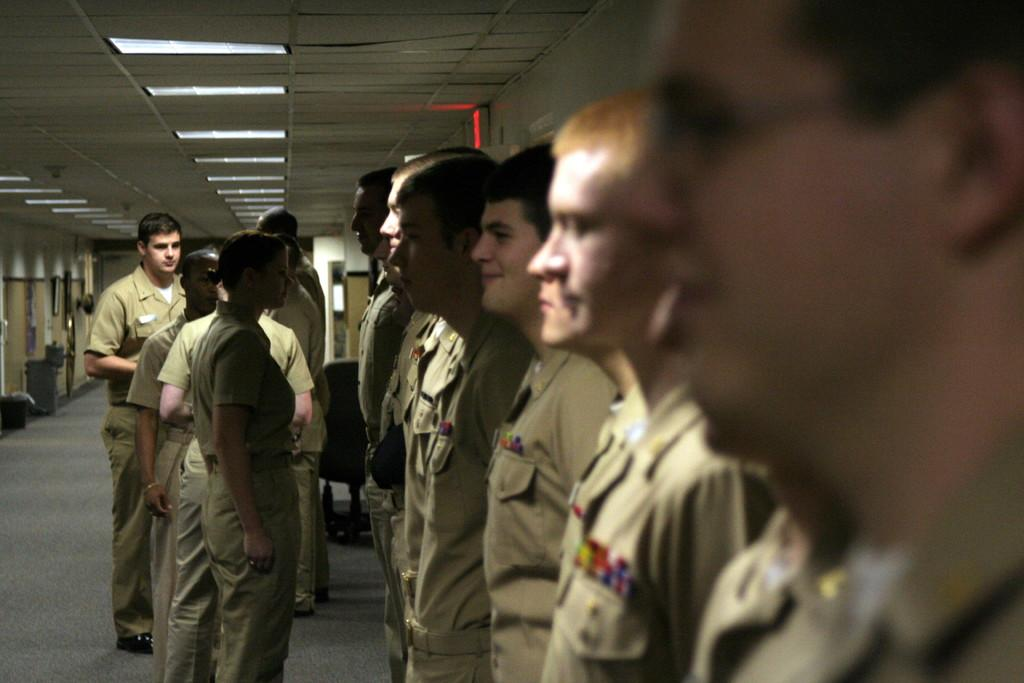How many people are present in the image? There are multiple persons standing in the image. What can be seen in the background of the image? There is a chair, photo frames, a wall, and lights in the background of the image. What type of plane can be seen flying in the image? There is no plane visible in the image. Is there a mailbox present in the image? No, there is no mailbox present in the image. 